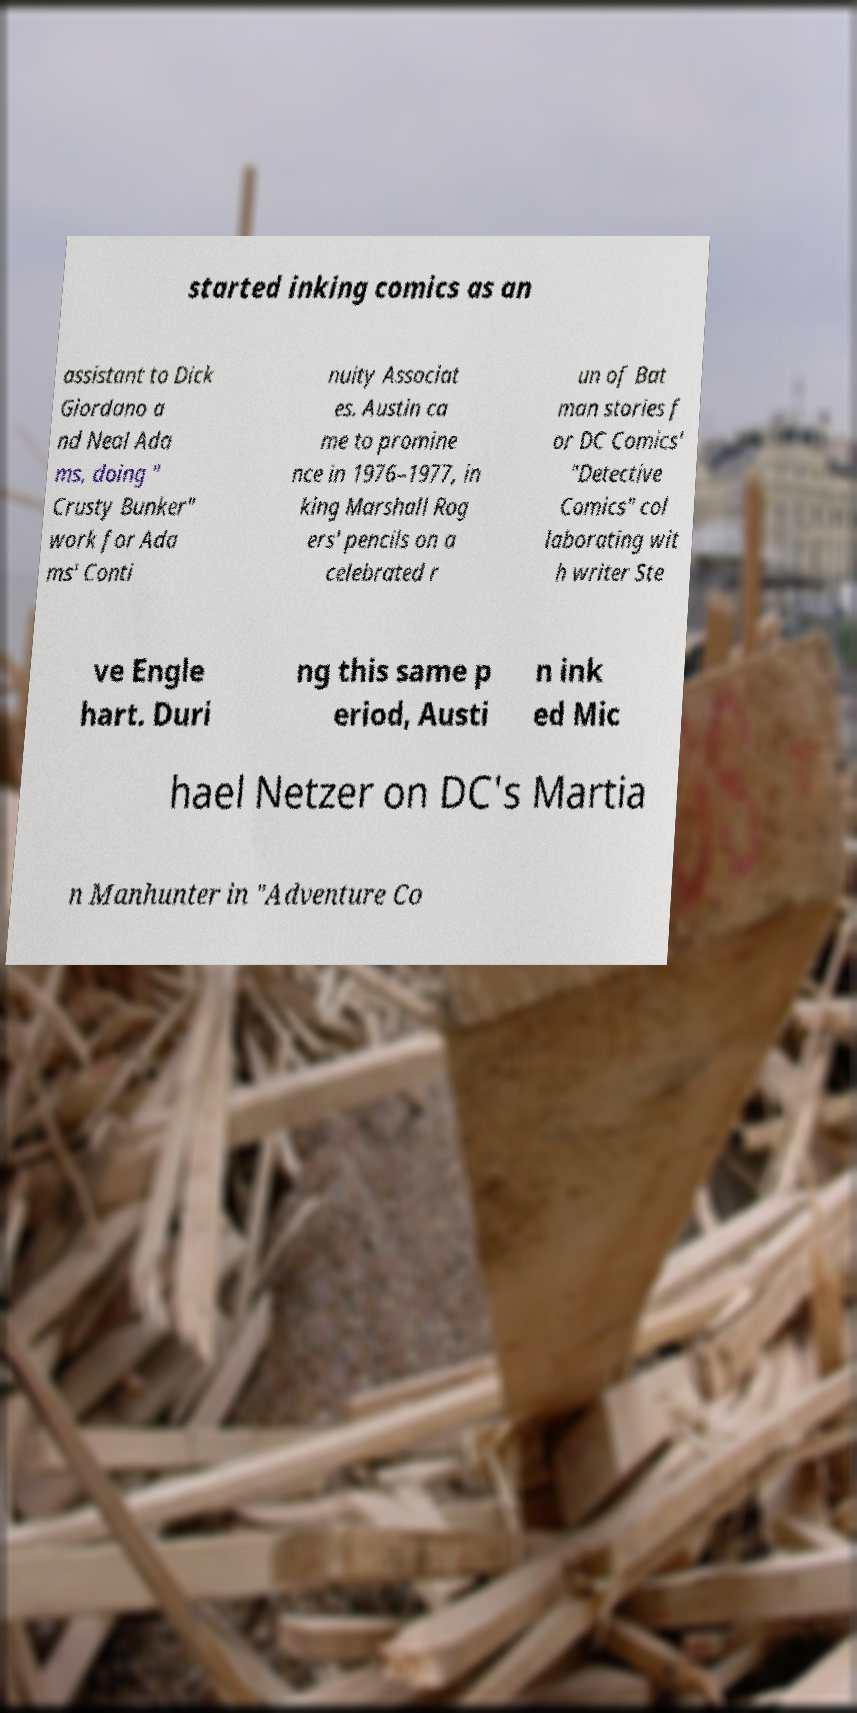Could you extract and type out the text from this image? started inking comics as an assistant to Dick Giordano a nd Neal Ada ms, doing " Crusty Bunker" work for Ada ms' Conti nuity Associat es. Austin ca me to promine nce in 1976–1977, in king Marshall Rog ers' pencils on a celebrated r un of Bat man stories f or DC Comics' "Detective Comics" col laborating wit h writer Ste ve Engle hart. Duri ng this same p eriod, Austi n ink ed Mic hael Netzer on DC's Martia n Manhunter in "Adventure Co 